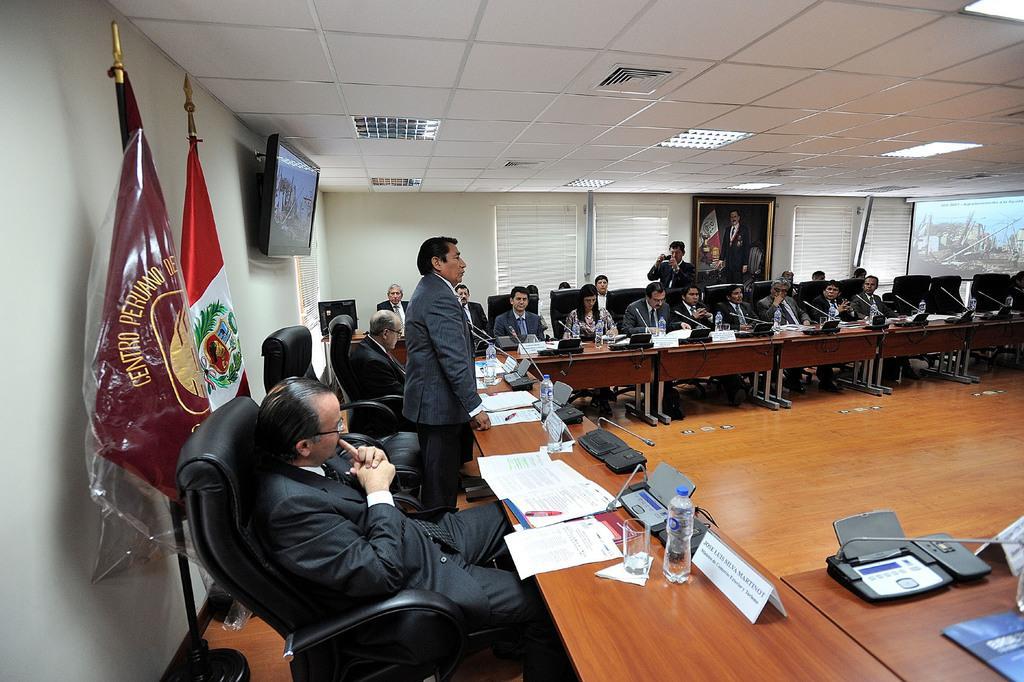Describe this image in one or two sentences. This picture shows a meeting room where a group of people seated on the chairs and we see few water bottles , glasses and papers and microphones on the table and we see a man standing and speaking and we see other Man Standing and taking a video with the help of a camera and we see a projector screen and a television and two flags on their back 